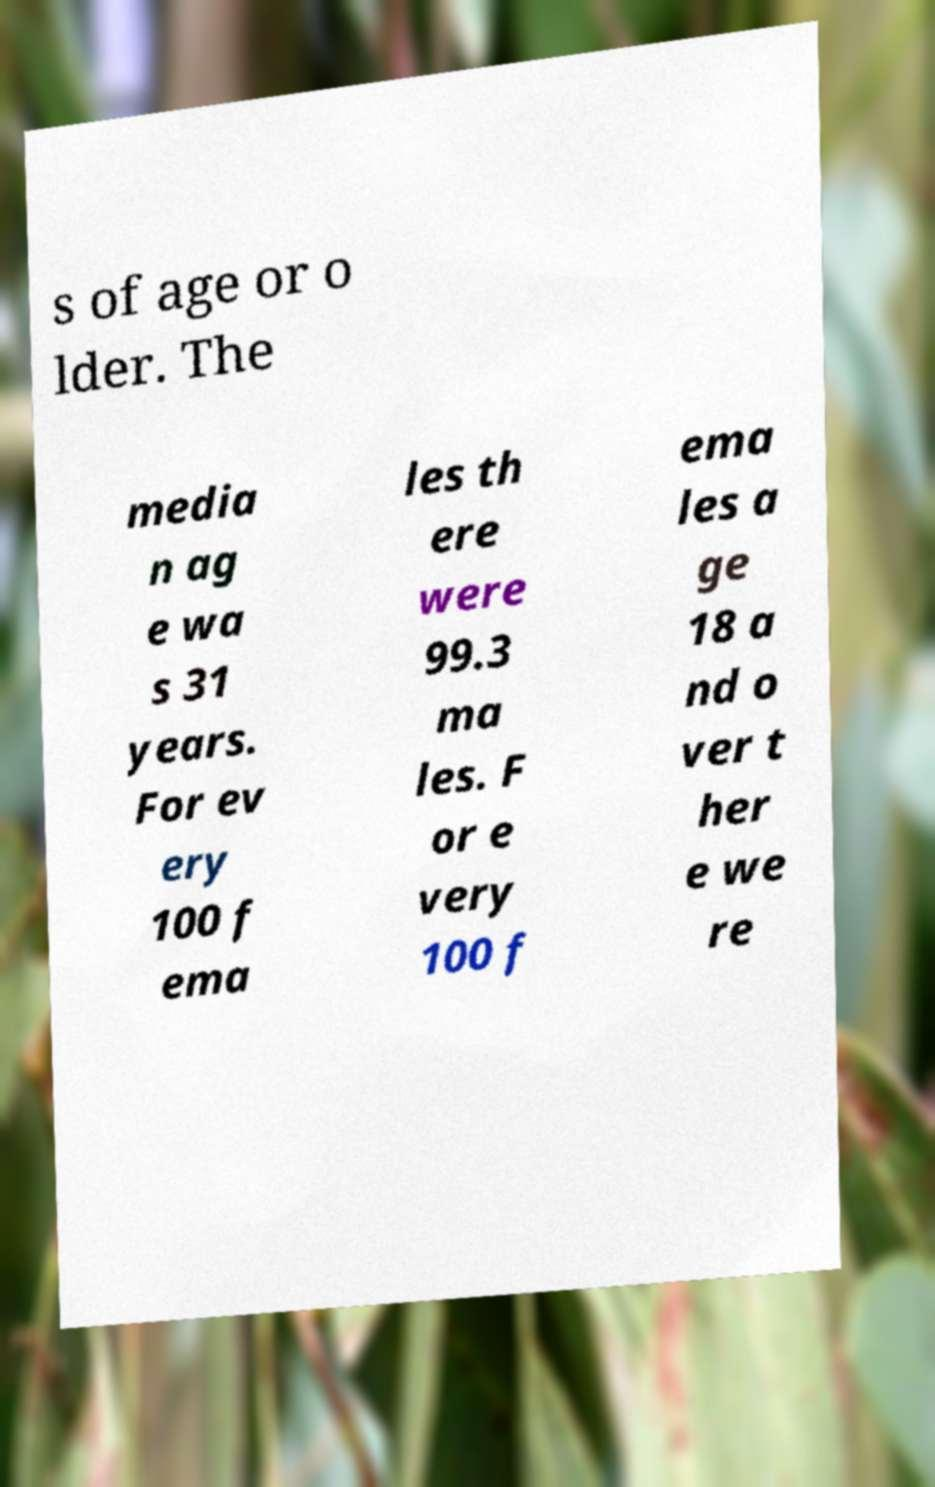Can you accurately transcribe the text from the provided image for me? s of age or o lder. The media n ag e wa s 31 years. For ev ery 100 f ema les th ere were 99.3 ma les. F or e very 100 f ema les a ge 18 a nd o ver t her e we re 